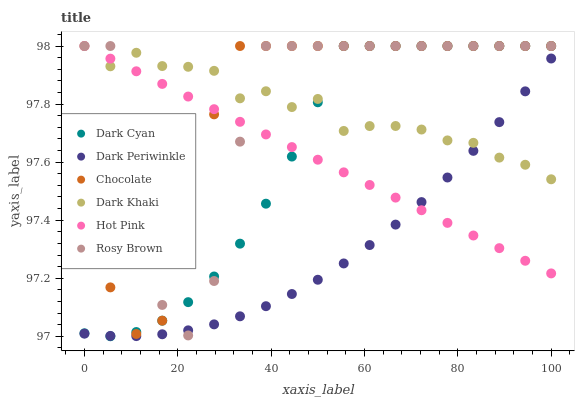Does Dark Periwinkle have the minimum area under the curve?
Answer yes or no. Yes. Does Rosy Brown have the maximum area under the curve?
Answer yes or no. Yes. Does Chocolate have the minimum area under the curve?
Answer yes or no. No. Does Chocolate have the maximum area under the curve?
Answer yes or no. No. Is Hot Pink the smoothest?
Answer yes or no. Yes. Is Rosy Brown the roughest?
Answer yes or no. Yes. Is Chocolate the smoothest?
Answer yes or no. No. Is Chocolate the roughest?
Answer yes or no. No. Does Dark Cyan have the lowest value?
Answer yes or no. Yes. Does Rosy Brown have the lowest value?
Answer yes or no. No. Does Dark Cyan have the highest value?
Answer yes or no. Yes. Does Dark Periwinkle have the highest value?
Answer yes or no. No. Is Dark Periwinkle less than Chocolate?
Answer yes or no. Yes. Is Chocolate greater than Dark Periwinkle?
Answer yes or no. Yes. Does Hot Pink intersect Dark Periwinkle?
Answer yes or no. Yes. Is Hot Pink less than Dark Periwinkle?
Answer yes or no. No. Is Hot Pink greater than Dark Periwinkle?
Answer yes or no. No. Does Dark Periwinkle intersect Chocolate?
Answer yes or no. No. 